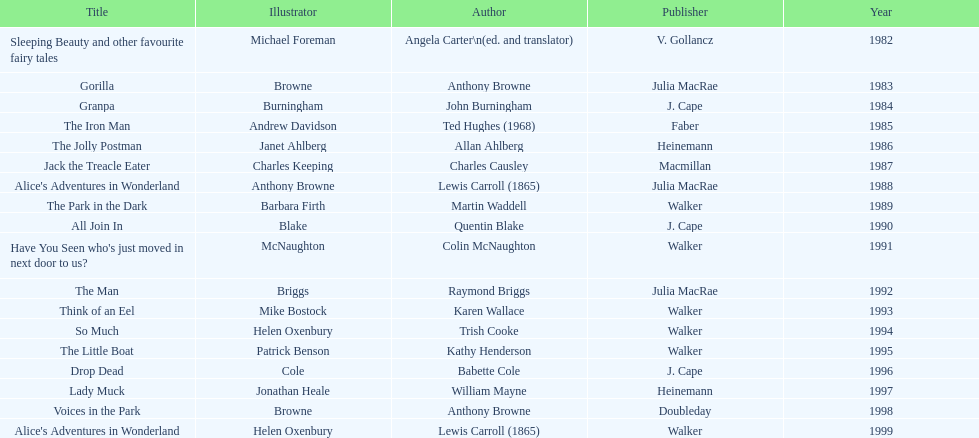Which book won the award a total of 2 times? Alice's Adventures in Wonderland. Parse the table in full. {'header': ['Title', 'Illustrator', 'Author', 'Publisher', 'Year'], 'rows': [['Sleeping Beauty and other favourite fairy tales', 'Michael Foreman', 'Angela Carter\\n(ed. and translator)', 'V. Gollancz', '1982'], ['Gorilla', 'Browne', 'Anthony Browne', 'Julia MacRae', '1983'], ['Granpa', 'Burningham', 'John Burningham', 'J. Cape', '1984'], ['The Iron Man', 'Andrew Davidson', 'Ted Hughes (1968)', 'Faber', '1985'], ['The Jolly Postman', 'Janet Ahlberg', 'Allan Ahlberg', 'Heinemann', '1986'], ['Jack the Treacle Eater', 'Charles Keeping', 'Charles Causley', 'Macmillan', '1987'], ["Alice's Adventures in Wonderland", 'Anthony Browne', 'Lewis Carroll (1865)', 'Julia MacRae', '1988'], ['The Park in the Dark', 'Barbara Firth', 'Martin Waddell', 'Walker', '1989'], ['All Join In', 'Blake', 'Quentin Blake', 'J. Cape', '1990'], ["Have You Seen who's just moved in next door to us?", 'McNaughton', 'Colin McNaughton', 'Walker', '1991'], ['The Man', 'Briggs', 'Raymond Briggs', 'Julia MacRae', '1992'], ['Think of an Eel', 'Mike Bostock', 'Karen Wallace', 'Walker', '1993'], ['So Much', 'Helen Oxenbury', 'Trish Cooke', 'Walker', '1994'], ['The Little Boat', 'Patrick Benson', 'Kathy Henderson', 'Walker', '1995'], ['Drop Dead', 'Cole', 'Babette Cole', 'J. Cape', '1996'], ['Lady Muck', 'Jonathan Heale', 'William Mayne', 'Heinemann', '1997'], ['Voices in the Park', 'Browne', 'Anthony Browne', 'Doubleday', '1998'], ["Alice's Adventures in Wonderland", 'Helen Oxenbury', 'Lewis Carroll (1865)', 'Walker', '1999']]} 